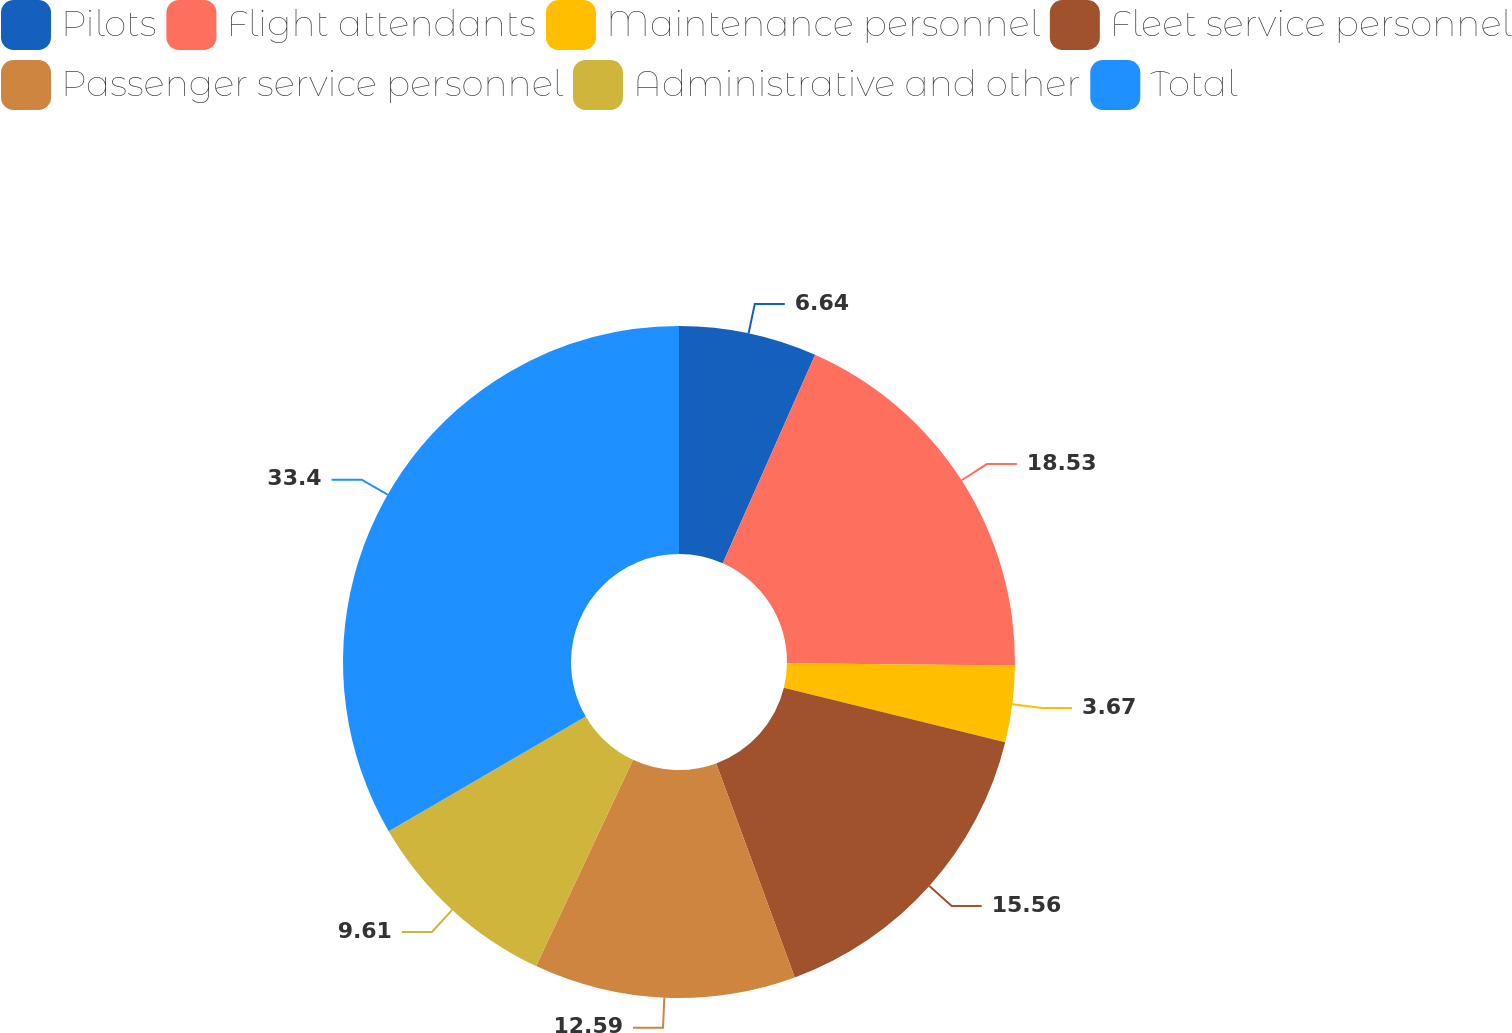Convert chart to OTSL. <chart><loc_0><loc_0><loc_500><loc_500><pie_chart><fcel>Pilots<fcel>Flight attendants<fcel>Maintenance personnel<fcel>Fleet service personnel<fcel>Passenger service personnel<fcel>Administrative and other<fcel>Total<nl><fcel>6.64%<fcel>18.53%<fcel>3.67%<fcel>15.56%<fcel>12.59%<fcel>9.61%<fcel>33.4%<nl></chart> 